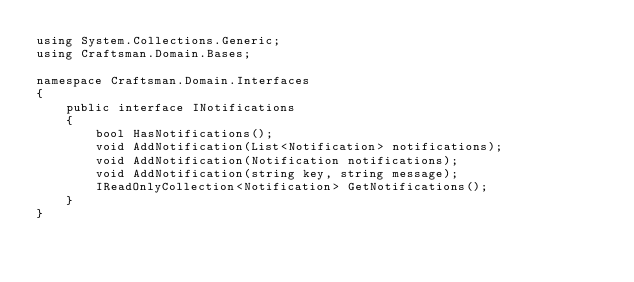Convert code to text. <code><loc_0><loc_0><loc_500><loc_500><_C#_>using System.Collections.Generic;
using Craftsman.Domain.Bases;

namespace Craftsman.Domain.Interfaces
{
    public interface INotifications
    {
        bool HasNotifications();
        void AddNotification(List<Notification> notifications);
        void AddNotification(Notification notifications);
        void AddNotification(string key, string message);
        IReadOnlyCollection<Notification> GetNotifications();
    }
}</code> 